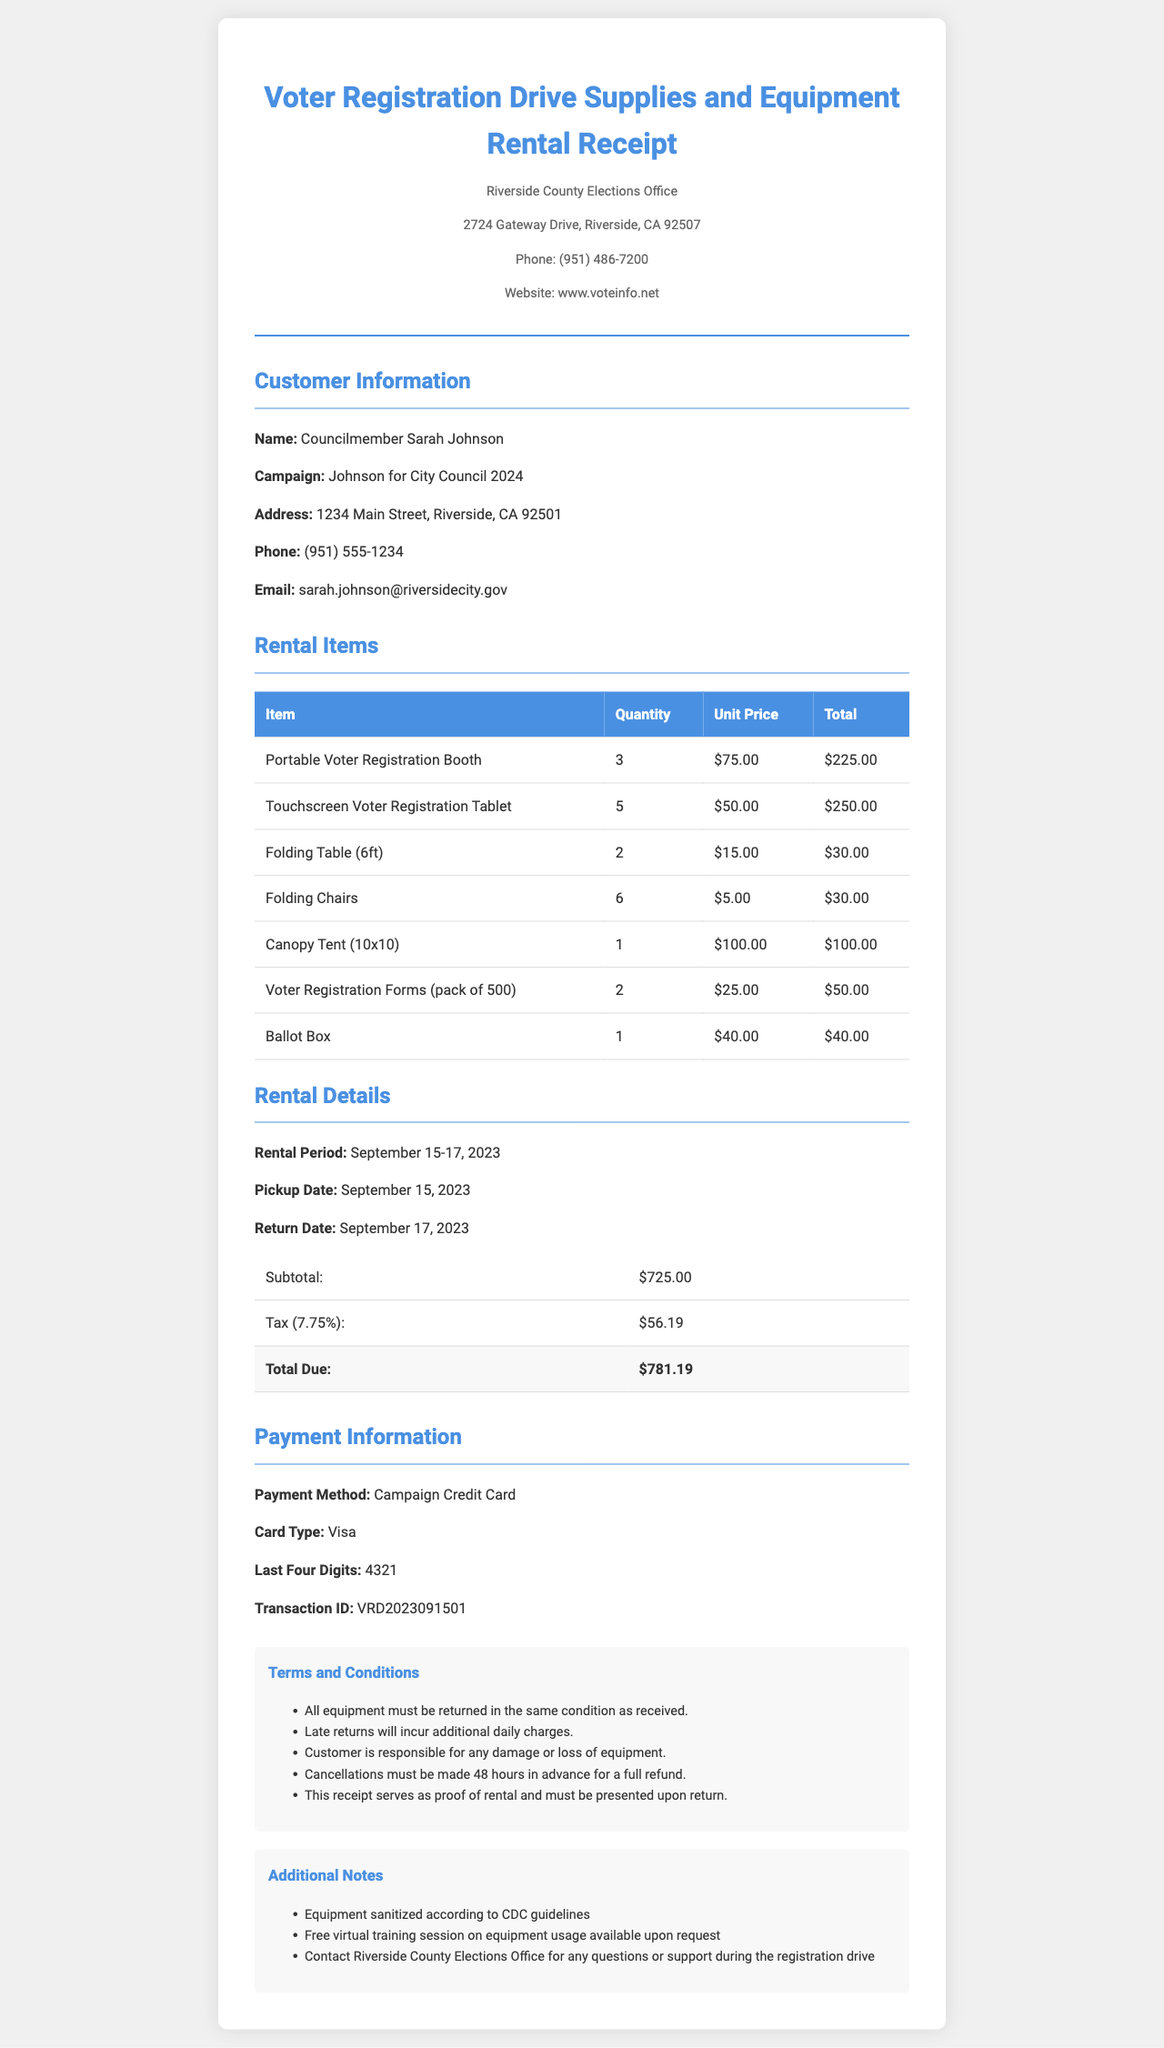what is the title of the document? The title is prominently displayed at the top of the receipt as "Voter Registration Drive Supplies and Equipment Rental Receipt."
Answer: Voter Registration Drive Supplies and Equipment Rental Receipt who is the customer? The customer information section provides the name of the customer as "Councilmember Sarah Johnson."
Answer: Councilmember Sarah Johnson what is the total due? The total amount due after subtotal and tax is specified in the rental details section as "$781.19."
Answer: $781.19 how many Portable Voter Registration Booths were rented? The quantity of Portable Voter Registration Booths is listed in the rental items section as "3."
Answer: 3 what is the tax rate applied? The rental details section mentions the tax rate as "7.75%."
Answer: 7.75% when is the pickup date? The pickup date is highlighted in the rental details as "September 15, 2023."
Answer: September 15, 2023 what method of payment was used? The payment information states that the payment method is "Campaign Credit Card."
Answer: Campaign Credit Card what is the quantity of Voter Registration Forms ordered? The rental items section indicates that "2" packs of Voter Registration Forms were rented.
Answer: 2 what should you do in case of late returns? The terms and conditions specify that late returns will incur additional daily charges, indicating a fee for late return.
Answer: Additional daily charges 